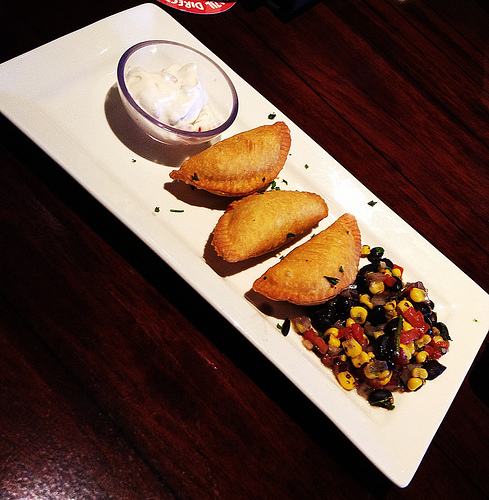<image>
Is the plate on the sour cream? No. The plate is not positioned on the sour cream. They may be near each other, but the plate is not supported by or resting on top of the sour cream. Where is the food in relation to the dip? Is it next to the dip? Yes. The food is positioned adjacent to the dip, located nearby in the same general area. 